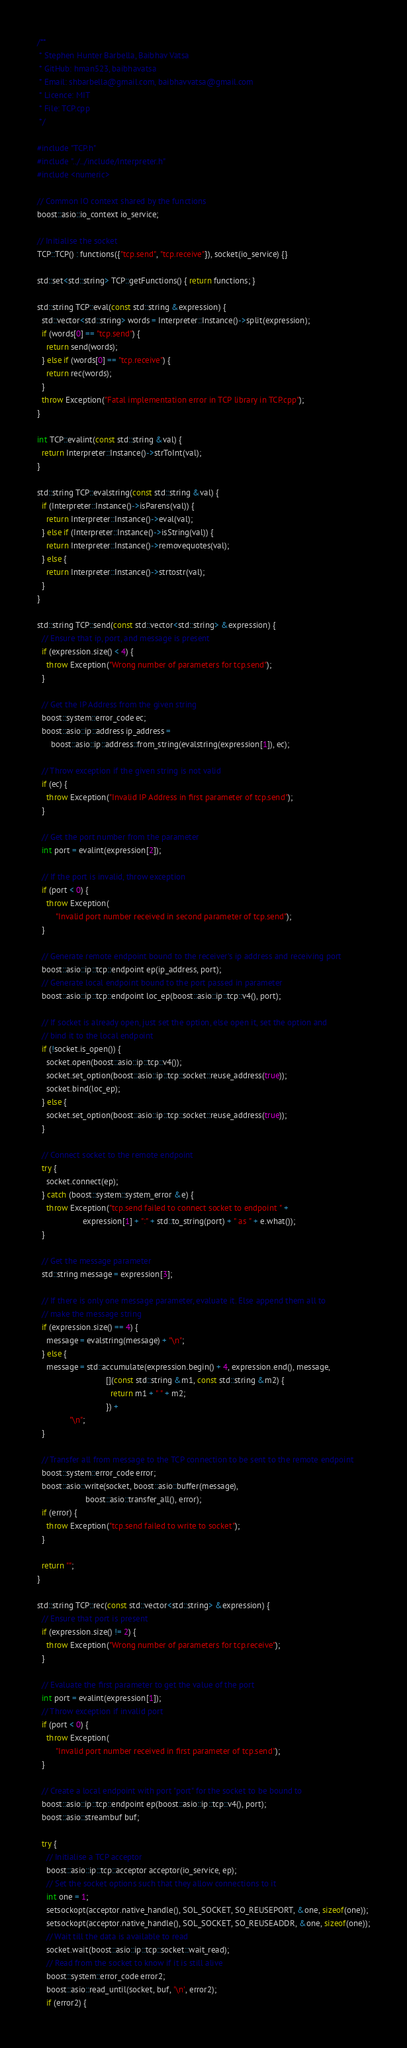<code> <loc_0><loc_0><loc_500><loc_500><_C++_>/**
 * Stephen Hunter Barbella, Baibhav Vatsa
 * GitHub: hman523, baibhavatsa
 * Email: shbarbella@gmail.com, baibhavvatsa@gmail.com
 * Licence: MIT
 * File: TCP.cpp
 */

#include "TCP.h"
#include "../../include/Interpreter.h"
#include <numeric>

// Common IO context shared by the functions
boost::asio::io_context io_service;

// Initialise the socket 
TCP::TCP() : functions({"tcp.send", "tcp.receive"}), socket(io_service) {}

std::set<std::string> TCP::getFunctions() { return functions; }

std::string TCP::eval(const std::string &expression) {
  std::vector<std::string> words = Interpreter::Instance()->split(expression);
  if (words[0] == "tcp.send") {
    return send(words);
  } else if (words[0] == "tcp.receive") {
    return rec(words);
  }
  throw Exception("Fatal implementation error in TCP library in TCP.cpp");
}

int TCP::evalint(const std::string &val) {
  return Interpreter::Instance()->strToInt(val);
}

std::string TCP::evalstring(const std::string &val) {
  if (Interpreter::Instance()->isParens(val)) {
    return Interpreter::Instance()->eval(val);
  } else if (Interpreter::Instance()->isString(val)) {
    return Interpreter::Instance()->removequotes(val);
  } else {
    return Interpreter::Instance()->strtostr(val);
  }
}

std::string TCP::send(const std::vector<std::string> &expression) {
  // Ensure that ip, port, and message is present
  if (expression.size() < 4) {
    throw Exception("Wrong number of parameters for tcp.send");
  }

  // Get the IP Address from the given string
  boost::system::error_code ec;
  boost::asio::ip::address ip_address =
      boost::asio::ip::address::from_string(evalstring(expression[1]), ec);

  // Throw exception if the given string is not valid
  if (ec) {
    throw Exception("Invalid IP Address in first parameter of tcp.send");
  }

  // Get the port number from the parameter
  int port = evalint(expression[2]);
  
  // If the port is invalid, throw exception
  if (port < 0) {
    throw Exception(
        "Invalid port number received in second parameter of tcp.send");
  }

  // Generate remote endpoint bound to the receiver's ip address and receiving port
  boost::asio::ip::tcp::endpoint ep(ip_address, port);
  // Generate local endpoint bound to the port passed in parameter
  boost::asio::ip::tcp::endpoint loc_ep(boost::asio::ip::tcp::v4(), port);

  // If socket is already open, just set the option, else open it, set the option and 
  // bind it to the local endpoint
  if (!socket.is_open()) {
    socket.open(boost::asio::ip::tcp::v4());
    socket.set_option(boost::asio::ip::tcp::socket::reuse_address(true));
    socket.bind(loc_ep);
  } else {
    socket.set_option(boost::asio::ip::tcp::socket::reuse_address(true));
  }

  // Connect socket to the remote endpoint
  try {
    socket.connect(ep);
  } catch (boost::system::system_error &e) {
    throw Exception("tcp.send failed to connect socket to endpoint " +
                    expression[1] + ":" + std::to_string(port) + " as " + e.what());
  }

  // Get the message parameter
  std::string message = expression[3];

  // If there is only one message parameter, evaluate it. Else append them all to 
  // make the message string
  if (expression.size() == 4) {
    message = evalstring(message) + "\n";
  } else {
    message = std::accumulate(expression.begin() + 4, expression.end(), message,
                              [](const std::string &m1, const std::string &m2) {
                                return m1 + " " + m2;
                              }) +
              "\n";
  }

  // Transfer all from message to the TCP connection to be sent to the remote endpoint
  boost::system::error_code error;
  boost::asio::write(socket, boost::asio::buffer(message),
                     boost::asio::transfer_all(), error);
  if (error) {
    throw Exception("tcp.send failed to write to socket");
  }

  return "";
}

std::string TCP::rec(const std::vector<std::string> &expression) {
  // Ensure that port is present
  if (expression.size() != 2) {
    throw Exception("Wrong number of parameters for tcp.receive");
  }

  // Evaluate the first parameter to get the value of the port 
  int port = evalint(expression[1]);
  // Throw exception if invalid port
  if (port < 0) {
    throw Exception(
        "Invalid port number received in first parameter of tcp.send");
  }

  // Create a local endpoint with port "port" for the socket to be bound to
  boost::asio::ip::tcp::endpoint ep(boost::asio::ip::tcp::v4(), port);
  boost::asio::streambuf buf;

  try {
    // Initialise a TCP acceptor
    boost::asio::ip::tcp::acceptor acceptor(io_service, ep);
    // Set the socket options such that they allow connections to it
    int one = 1;
    setsockopt(acceptor.native_handle(), SOL_SOCKET, SO_REUSEPORT, &one, sizeof(one));
    setsockopt(acceptor.native_handle(), SOL_SOCKET, SO_REUSEADDR, &one, sizeof(one));
    // Wait till the data is available to read
    socket.wait(boost::asio::ip::tcp::socket::wait_read);
    // Read from the socket to know if it is still alive
    boost::system::error_code error2;
    boost::asio::read_until(socket, buf, '\n', error2);
    if (error2) {</code> 